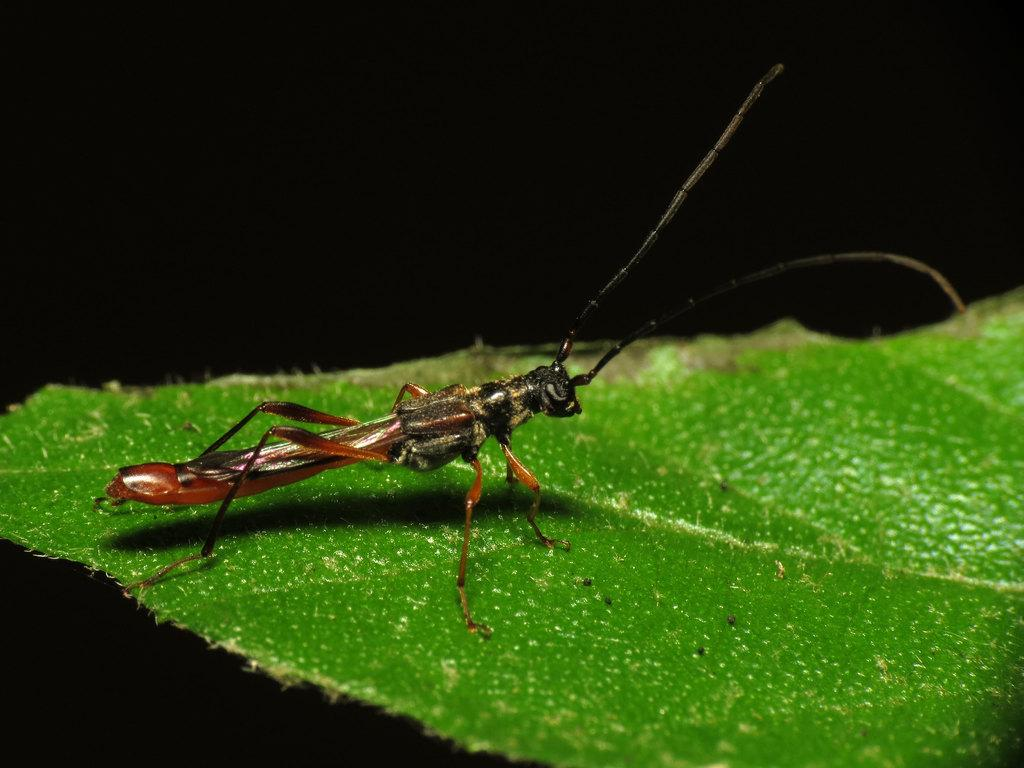What is present on the leaf in the image? There is an insect on a leaf in the image. What can be observed about the overall lighting or color of the image? The background of the image is dark. What type of vase is visible in the image? There is no vase present in the image. How does the insect grip the leaf in the image? The image does not show the insect gripping the leaf, so it is not possible to determine how it grips the leaf. 